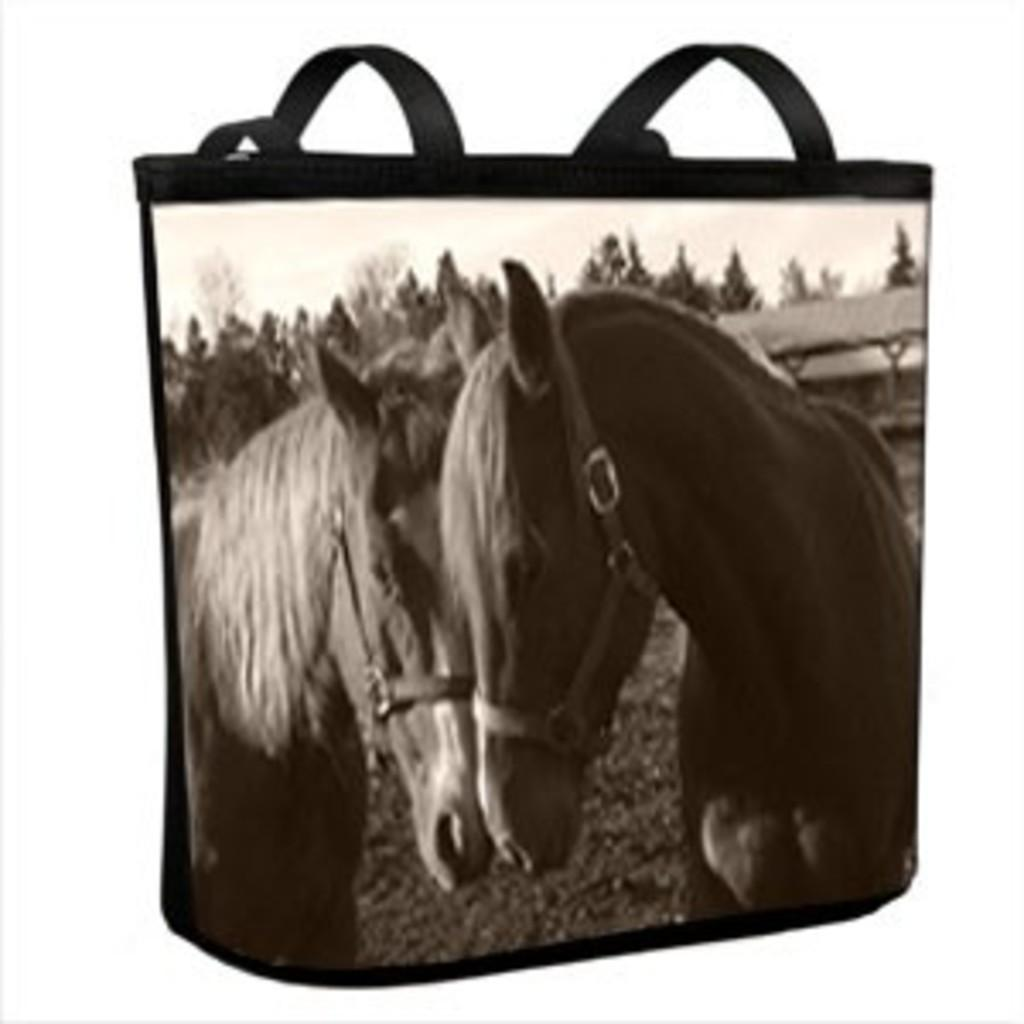What animals can be seen in the image? There are horses in the image. What type of vegetation is present in the image? There are trees in the image. What type of structure can be seen in the image? There is a shed in the image. How many clocks can be seen hanging from the trees in the image? There are no clocks visible in the image; it features horses, trees, and a shed. Can you describe the type of bread being eaten by the lizards in the image? There are no lizards present in the image, so it is not possible to describe any bread they might be eating. 